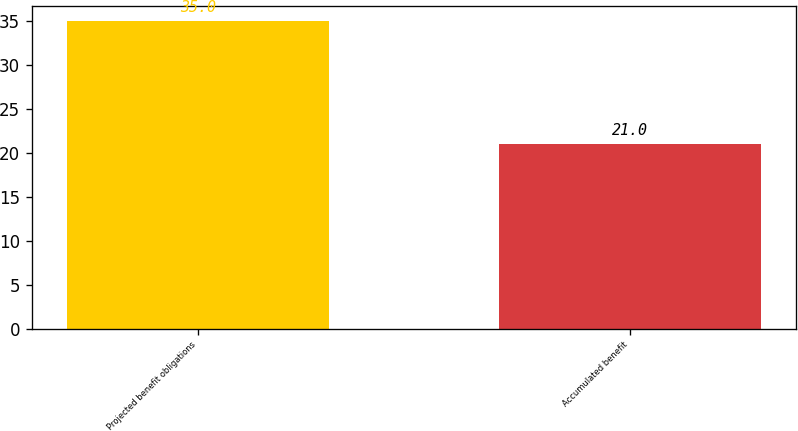<chart> <loc_0><loc_0><loc_500><loc_500><bar_chart><fcel>Projected benefit obligations<fcel>Accumulated benefit<nl><fcel>35<fcel>21<nl></chart> 